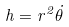<formula> <loc_0><loc_0><loc_500><loc_500>h = r ^ { 2 } { \dot { \theta } }</formula> 